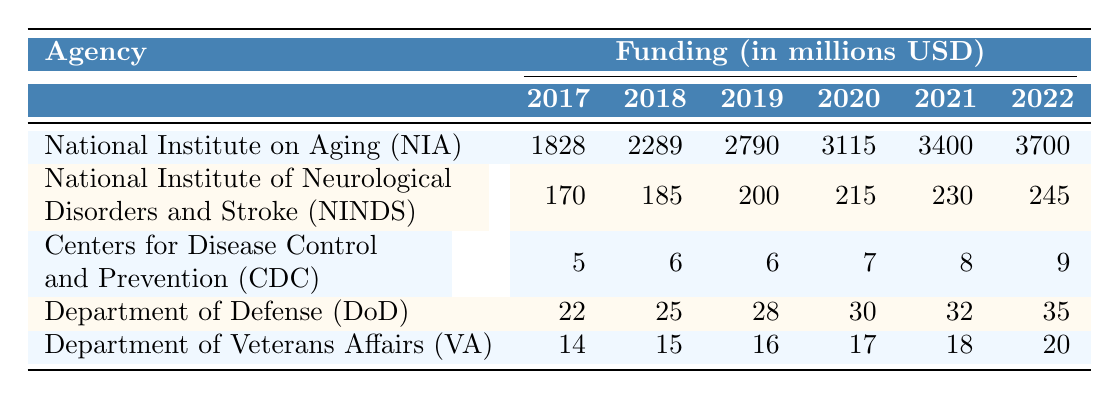What was the funding amount for the National Institute on Aging (NIA) in 2022? The table shows the funding for the National Institute on Aging (NIA) in 2022 as 3700 million USD.
Answer: 3700 million USD Which agency received the least funding in 2019? In 2019, the Centers for Disease Control and Prevention (CDC) received 6 million USD, which is less than the other agencies' funding for that year.
Answer: Centers for Disease Control and Prevention (CDC) What is the total funding for the Department of Veterans Affairs (VA) from 2017 to 2022? To find the total funding for VA from 2017 to 2022, we sum the amounts: 14 + 15 + 16 + 17 + 18 + 20 = 100 million USD.
Answer: 100 million USD Did the funding for the National Institute of Neurological Disorders and Stroke (NINDS) increase every year? Yes, the funding for NINDS increased consistently every year from 2017 to 2022, as observed in the table.
Answer: Yes What is the percentage increase in funding for the National Institute on Aging (NIA) from 2017 to 2022? The funding for NIA in 2017 was 1828 million USD and in 2022 was 3700 million USD. The increase is 3700 - 1828 = 1872 million USD. The percentage increase is (1872 / 1828) * 100 ≈ 102.4%.
Answer: Approximately 102.4% Which agency had the highest funding in 2021, and how much was it? In 2021, the National Institute on Aging (NIA) had the highest funding of 3400 million USD compared to the other agencies.
Answer: National Institute on Aging (NIA), 3400 million USD What was the average annual funding for the Department of Defense (DoD) from 2017 to 2022? The funding amounts for DoD from 2017 to 2022 are 22, 25, 28, 30, 32, and 35 million USD. The total funding is 22 + 25 + 28 + 30 + 32 + 35 = 172 million USD. The average is 172 / 6 ≈ 28.67 million USD.
Answer: Approximately 28.67 million USD Is the funding amount for the CDC equal to the funding amount for the VA in 2018? The CDC received 6 million USD and the VA received 15 million USD in 2018, so they are not equal.
Answer: No How much more funding did the National Institute on Aging (NIA) receive than the Department of Veterans Affairs (VA) in 2020? In 2020, NIA received 3115 million USD and VA received 17 million USD. The difference is 3115 - 17 = 3098 million USD.
Answer: 3098 million USD 